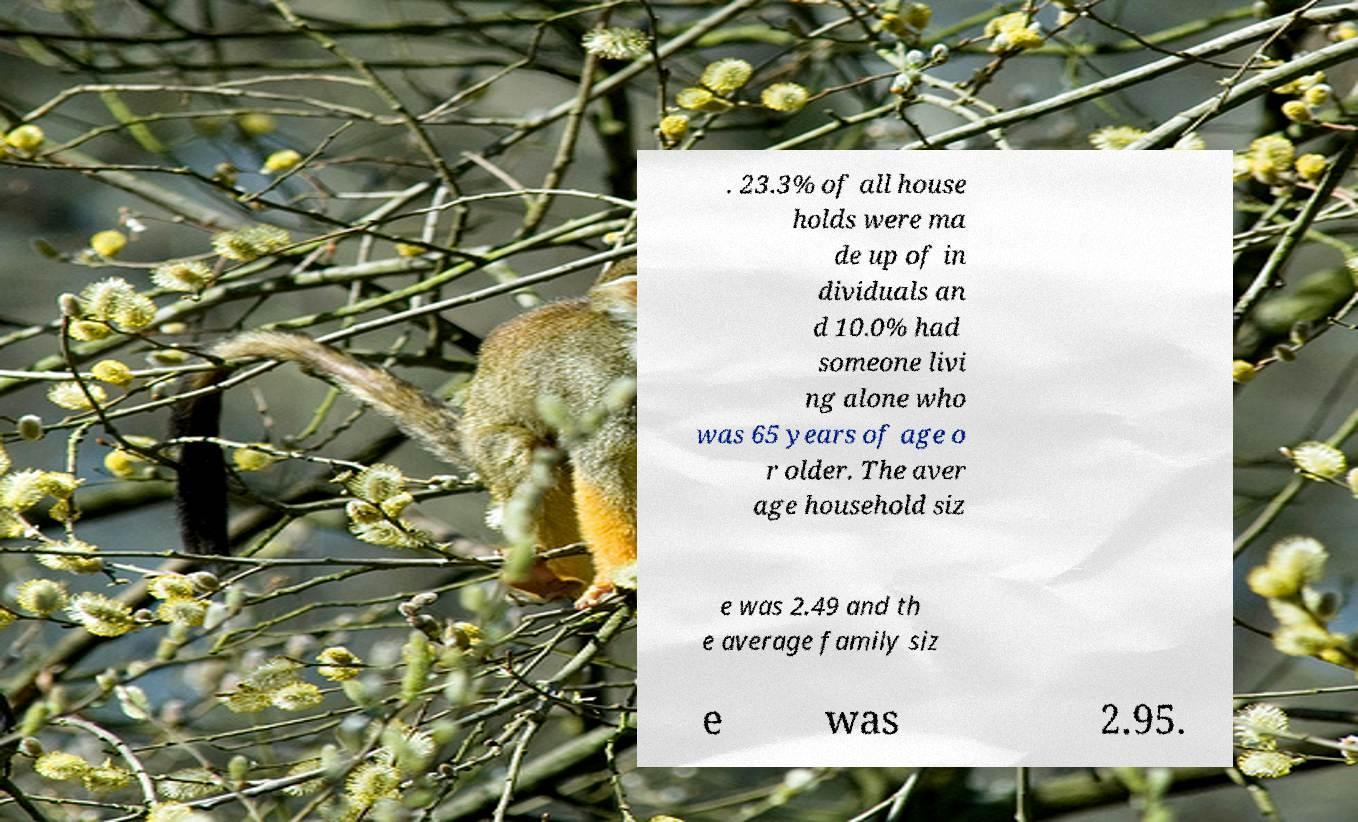I need the written content from this picture converted into text. Can you do that? . 23.3% of all house holds were ma de up of in dividuals an d 10.0% had someone livi ng alone who was 65 years of age o r older. The aver age household siz e was 2.49 and th e average family siz e was 2.95. 